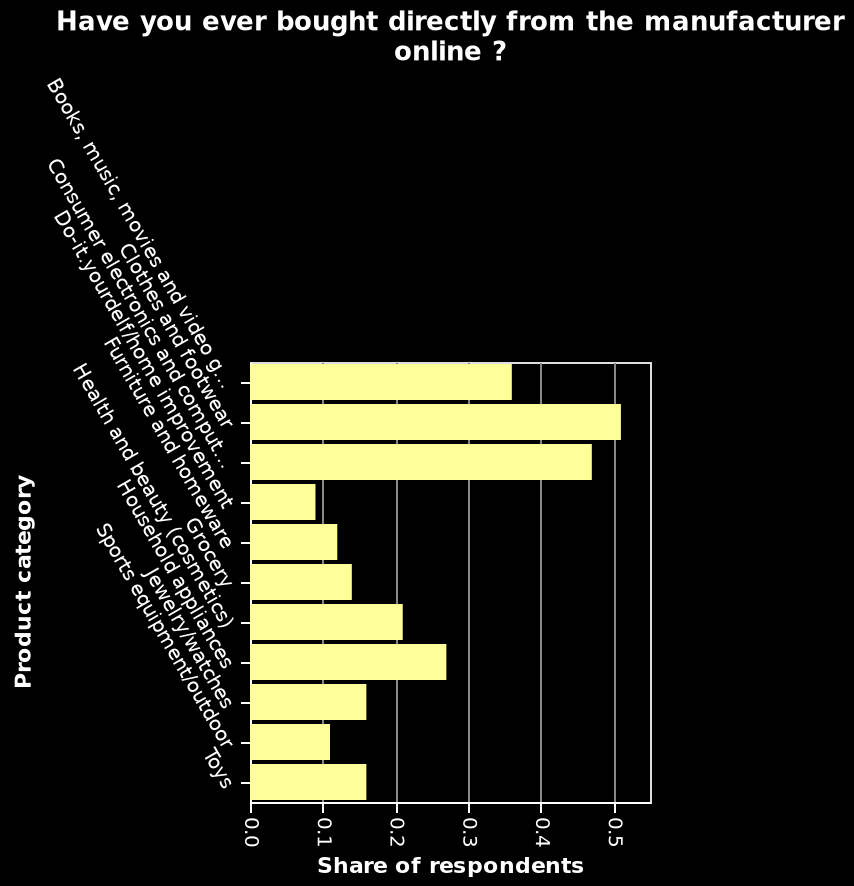<image>
Among all the items, which ones have lower chances of being purchased directly? Furniture and sports equipment. What are the minimum and maximum values on the x-axis? The minimum value on the x-axis is 0.0 and the maximum value is 0.5. What is the title of the bar diagram? The bar diagram is titled "Have you ever bought directly from the manufacturer online?" Is the minimum value on the x-axis 1.0 and the maximum value -0.5? No.The minimum value on the x-axis is 0.0 and the maximum value is 0.5. 